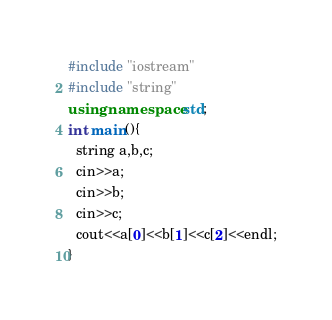<code> <loc_0><loc_0><loc_500><loc_500><_C++_>#include "iostream"
#include "string"
using namespace std;
int main(){
  string a,b,c;
  cin>>a;
  cin>>b;
  cin>>c;
  cout<<a[0]<<b[1]<<c[2]<<endl;
}
</code> 